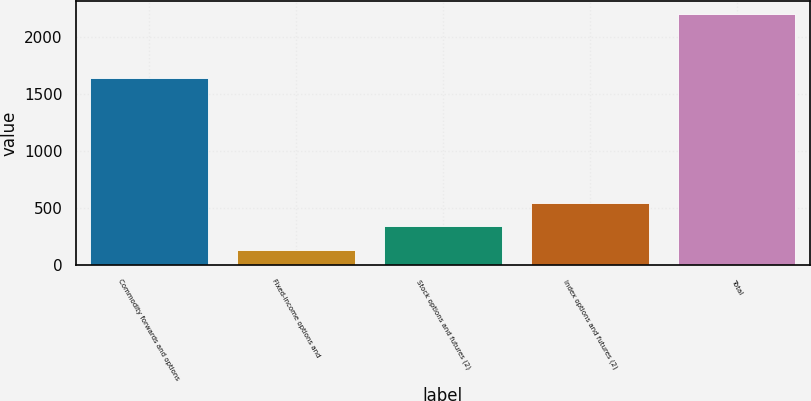Convert chart to OTSL. <chart><loc_0><loc_0><loc_500><loc_500><bar_chart><fcel>Commodity forwards and options<fcel>Fixed-income options and<fcel>Stock options and futures (2)<fcel>Index options and futures (2)<fcel>Total<nl><fcel>1642<fcel>131<fcel>338.1<fcel>545.2<fcel>2202<nl></chart> 